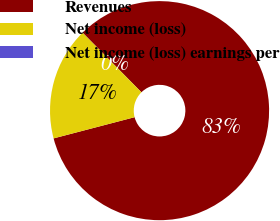Convert chart. <chart><loc_0><loc_0><loc_500><loc_500><pie_chart><fcel>Revenues<fcel>Net income (loss)<fcel>Net income (loss) earnings per<nl><fcel>83.32%<fcel>16.67%<fcel>0.01%<nl></chart> 